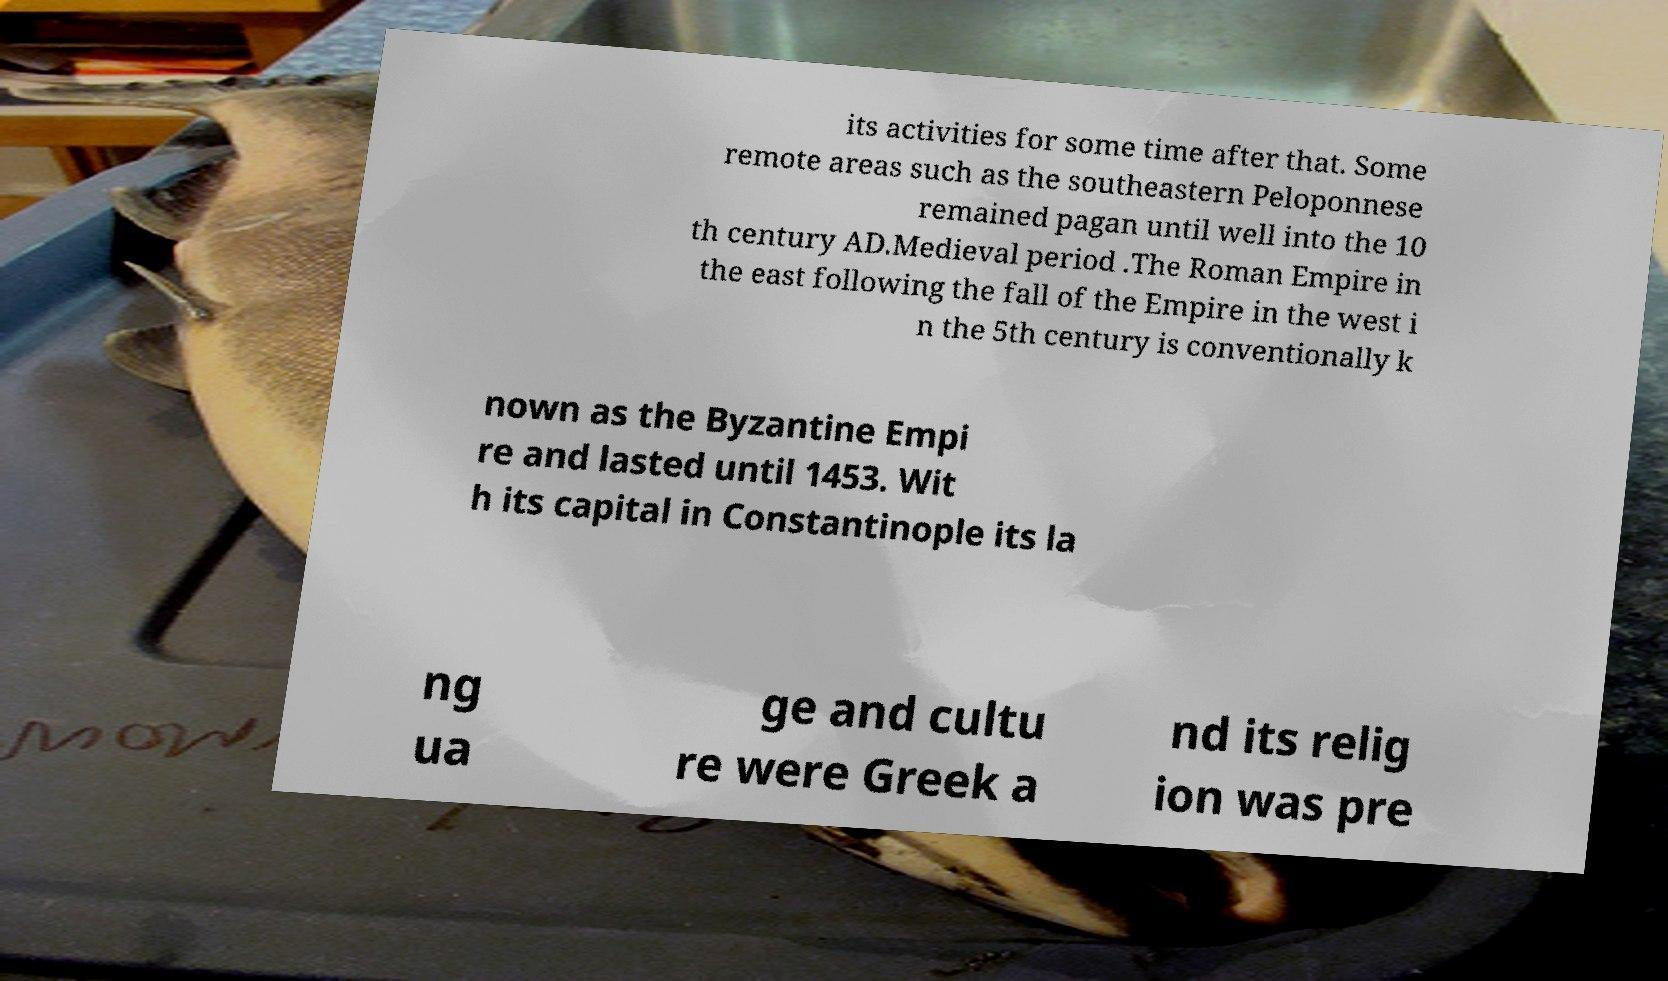Can you read and provide the text displayed in the image?This photo seems to have some interesting text. Can you extract and type it out for me? its activities for some time after that. Some remote areas such as the southeastern Peloponnese remained pagan until well into the 10 th century AD.Medieval period .The Roman Empire in the east following the fall of the Empire in the west i n the 5th century is conventionally k nown as the Byzantine Empi re and lasted until 1453. Wit h its capital in Constantinople its la ng ua ge and cultu re were Greek a nd its relig ion was pre 